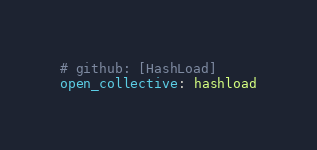<code> <loc_0><loc_0><loc_500><loc_500><_YAML_># github: [HashLoad]
open_collective: hashload
</code> 